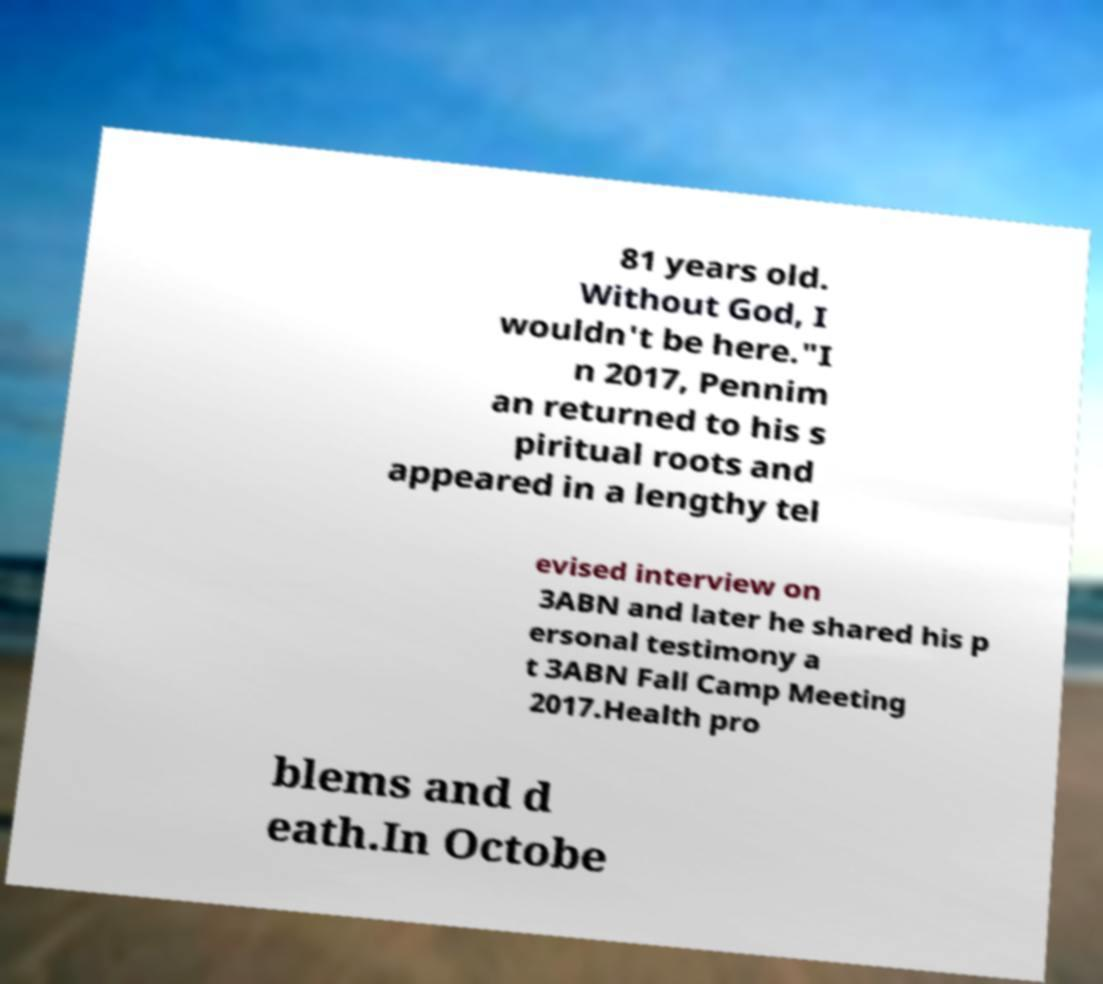Could you assist in decoding the text presented in this image and type it out clearly? 81 years old. Without God, I wouldn't be here."I n 2017, Pennim an returned to his s piritual roots and appeared in a lengthy tel evised interview on 3ABN and later he shared his p ersonal testimony a t 3ABN Fall Camp Meeting 2017.Health pro blems and d eath.In Octobe 